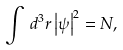Convert formula to latex. <formula><loc_0><loc_0><loc_500><loc_500>\int \, d ^ { 3 } r \left | \psi \right | ^ { 2 } = N ,</formula> 